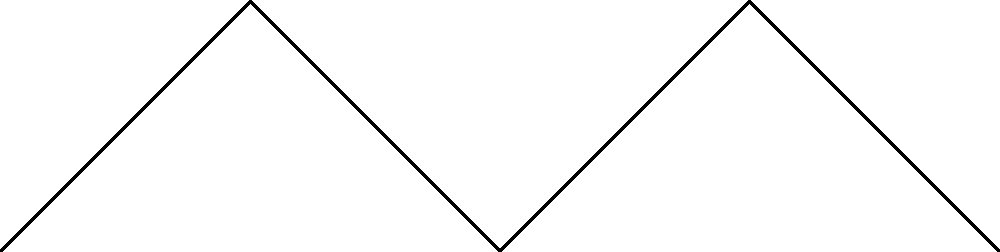As a tactical mastermind, you're devising a new formation for your team to counter Sheffield Wednesday F.C. The graph represents player positions, where adjacent vertices cannot have the same role. If you have 3 distinct roles (Forward, Midfielder, Defender) to assign, what is the minimum number of additional roles needed to create a valid formation? To solve this graph coloring problem and determine the minimum number of additional roles needed, we'll follow these steps:

1) First, we need to understand that this is a graph coloring problem where each color represents a role, and adjacent vertices (connected by an edge) cannot have the same color.

2) We start with 3 colors (roles): Forward, Midfielder, and Defender.

3) Analyze the graph structure:
   - It's a 5-vertex graph with a specific pattern of connections.
   - The graph has a chromatic number of 4, meaning it requires at least 4 colors for a proper coloring.

4) Try to color the graph with the given 3 colors:
   - P1: Forward
   - P2: Midfielder
   - P3: Defender
   - P4: We can't use any of the existing colors as P4 is connected to all of them.

5) We need to introduce a new role (color) for P4.
   - P4: New Role (let's call it 'Winger')

6) For P5, we can use one of the existing colors, as it's only connected to P3 and P4.
   - P5: Forward or Midfielder

Therefore, we need 1 additional role (Winger) to create a valid formation that satisfies the constraints of the graph.
Answer: 1 